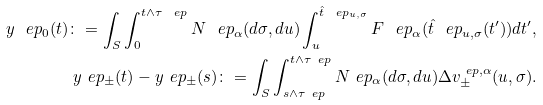<formula> <loc_0><loc_0><loc_500><loc_500>y ^ { \ } e p _ { 0 } ( t ) \colon = \int _ { S } \int _ { 0 } ^ { t \wedge \tau ^ { \ } e p } N ^ { \ } e p _ { \alpha } ( d \sigma , d u ) \int _ { u } ^ { \hat { t } ^ { \ } e p _ { u , \sigma } } F ^ { \ } e p _ { \alpha } ( \hat { t } ^ { \ } e p _ { u , \sigma } ( t ^ { \prime } ) ) d t ^ { \prime } , \\ y ^ { \ } e p _ { \pm } ( t ) - y ^ { \ } e p _ { \pm } ( s ) \colon = \int _ { S } \int _ { s \wedge \tau ^ { \ } e p } ^ { t \wedge \tau ^ { \ } e p } N ^ { \ } e p _ { \alpha } ( d \sigma , d u ) \Delta v ^ { \ e p , \alpha } _ { \pm } ( u , \sigma ) .</formula> 